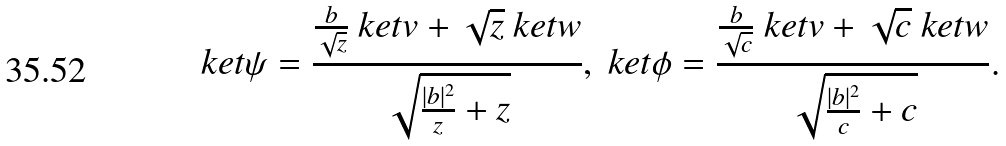Convert formula to latex. <formula><loc_0><loc_0><loc_500><loc_500>\ k e t { \psi } = \frac { \frac { b } { \sqrt { z } } \ k e t { v } + \sqrt { z } \ k e t { w } } { \sqrt { \frac { | b | ^ { 2 } } { z } + z } } , \ k e t { \phi } = \frac { \frac { b } { \sqrt { c } } \ k e t { v } + \sqrt { c } \ k e t { w } } { \sqrt { \frac { | b | ^ { 2 } } { c } + c } } .</formula> 